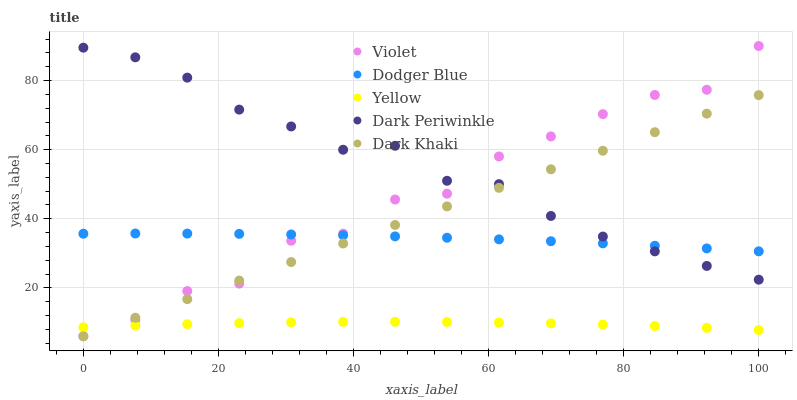Does Yellow have the minimum area under the curve?
Answer yes or no. Yes. Does Dark Periwinkle have the maximum area under the curve?
Answer yes or no. Yes. Does Dodger Blue have the minimum area under the curve?
Answer yes or no. No. Does Dodger Blue have the maximum area under the curve?
Answer yes or no. No. Is Dark Khaki the smoothest?
Answer yes or no. Yes. Is Violet the roughest?
Answer yes or no. Yes. Is Dodger Blue the smoothest?
Answer yes or no. No. Is Dodger Blue the roughest?
Answer yes or no. No. Does Dark Khaki have the lowest value?
Answer yes or no. Yes. Does Dark Periwinkle have the lowest value?
Answer yes or no. No. Does Violet have the highest value?
Answer yes or no. Yes. Does Dodger Blue have the highest value?
Answer yes or no. No. Is Yellow less than Dark Periwinkle?
Answer yes or no. Yes. Is Dodger Blue greater than Yellow?
Answer yes or no. Yes. Does Dark Periwinkle intersect Dark Khaki?
Answer yes or no. Yes. Is Dark Periwinkle less than Dark Khaki?
Answer yes or no. No. Is Dark Periwinkle greater than Dark Khaki?
Answer yes or no. No. Does Yellow intersect Dark Periwinkle?
Answer yes or no. No. 